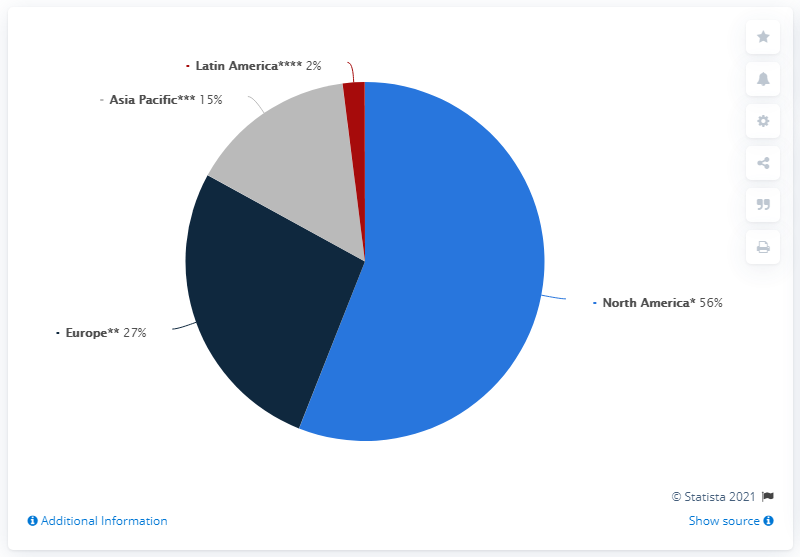Give some essential details in this illustration. The Asian Pacific sales are gray. North America and Europe combined account for approximately 83% of the company's sales. 